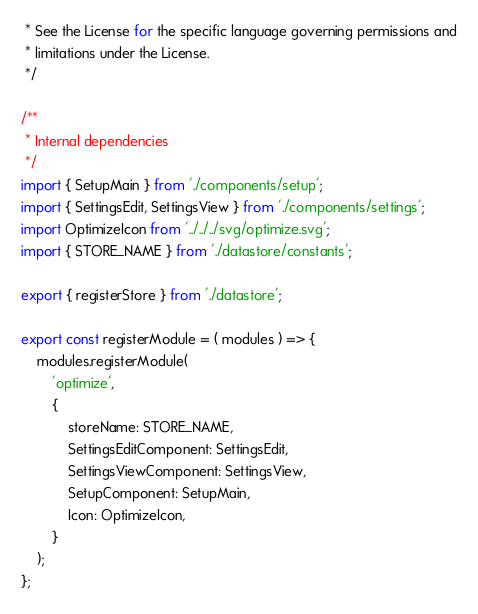Convert code to text. <code><loc_0><loc_0><loc_500><loc_500><_JavaScript_> * See the License for the specific language governing permissions and
 * limitations under the License.
 */

/**
 * Internal dependencies
 */
import { SetupMain } from './components/setup';
import { SettingsEdit, SettingsView } from './components/settings';
import OptimizeIcon from '../../../svg/optimize.svg';
import { STORE_NAME } from './datastore/constants';

export { registerStore } from './datastore';

export const registerModule = ( modules ) => {
	modules.registerModule(
		'optimize',
		{
			storeName: STORE_NAME,
			SettingsEditComponent: SettingsEdit,
			SettingsViewComponent: SettingsView,
			SetupComponent: SetupMain,
			Icon: OptimizeIcon,
		}
	);
};
</code> 